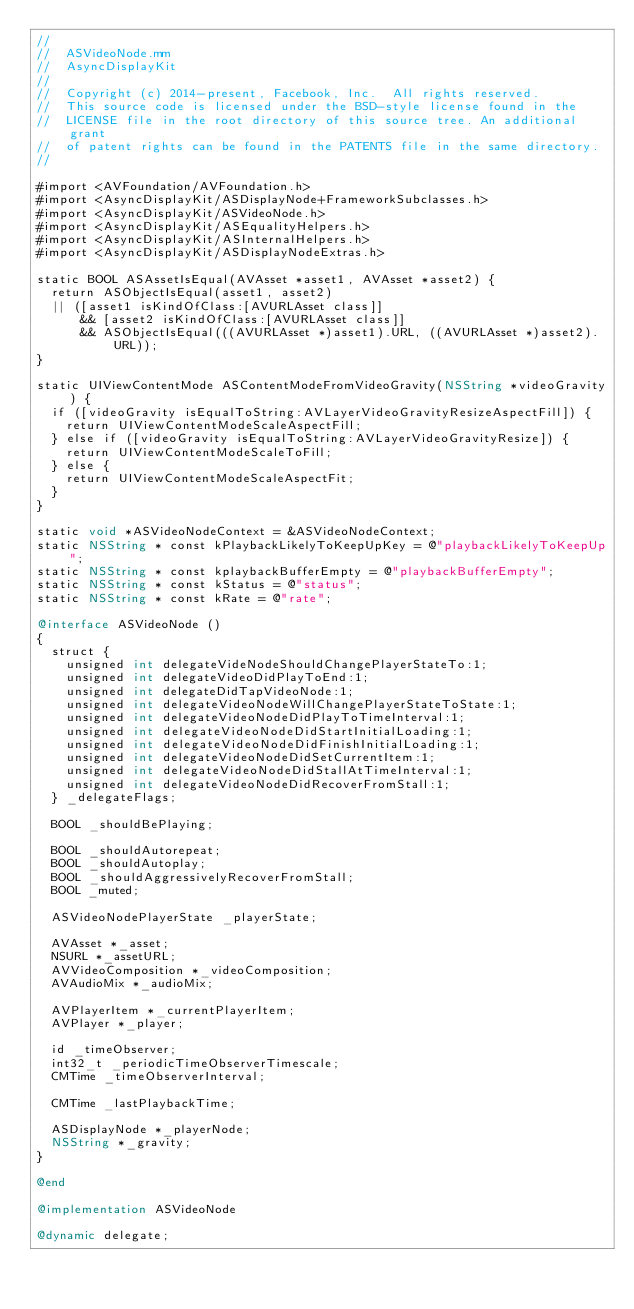Convert code to text. <code><loc_0><loc_0><loc_500><loc_500><_ObjectiveC_>//
//  ASVideoNode.mm
//  AsyncDisplayKit
//
//  Copyright (c) 2014-present, Facebook, Inc.  All rights reserved.
//  This source code is licensed under the BSD-style license found in the
//  LICENSE file in the root directory of this source tree. An additional grant
//  of patent rights can be found in the PATENTS file in the same directory.
//

#import <AVFoundation/AVFoundation.h>
#import <AsyncDisplayKit/ASDisplayNode+FrameworkSubclasses.h>
#import <AsyncDisplayKit/ASVideoNode.h>
#import <AsyncDisplayKit/ASEqualityHelpers.h>
#import <AsyncDisplayKit/ASInternalHelpers.h>
#import <AsyncDisplayKit/ASDisplayNodeExtras.h>

static BOOL ASAssetIsEqual(AVAsset *asset1, AVAsset *asset2) {
  return ASObjectIsEqual(asset1, asset2)
  || ([asset1 isKindOfClass:[AVURLAsset class]]
      && [asset2 isKindOfClass:[AVURLAsset class]]
      && ASObjectIsEqual(((AVURLAsset *)asset1).URL, ((AVURLAsset *)asset2).URL));
}

static UIViewContentMode ASContentModeFromVideoGravity(NSString *videoGravity) {
  if ([videoGravity isEqualToString:AVLayerVideoGravityResizeAspectFill]) {
    return UIViewContentModeScaleAspectFill;
  } else if ([videoGravity isEqualToString:AVLayerVideoGravityResize]) {
    return UIViewContentModeScaleToFill;
  } else {
    return UIViewContentModeScaleAspectFit;
  }
}

static void *ASVideoNodeContext = &ASVideoNodeContext;
static NSString * const kPlaybackLikelyToKeepUpKey = @"playbackLikelyToKeepUp";
static NSString * const kplaybackBufferEmpty = @"playbackBufferEmpty";
static NSString * const kStatus = @"status";
static NSString * const kRate = @"rate";

@interface ASVideoNode ()
{
  struct {
    unsigned int delegateVideNodeShouldChangePlayerStateTo:1;
    unsigned int delegateVideoDidPlayToEnd:1;
    unsigned int delegateDidTapVideoNode:1;
    unsigned int delegateVideoNodeWillChangePlayerStateToState:1;
    unsigned int delegateVideoNodeDidPlayToTimeInterval:1;
    unsigned int delegateVideoNodeDidStartInitialLoading:1;
    unsigned int delegateVideoNodeDidFinishInitialLoading:1;
    unsigned int delegateVideoNodeDidSetCurrentItem:1;
    unsigned int delegateVideoNodeDidStallAtTimeInterval:1;
    unsigned int delegateVideoNodeDidRecoverFromStall:1;
  } _delegateFlags;
  
  BOOL _shouldBePlaying;
  
  BOOL _shouldAutorepeat;
  BOOL _shouldAutoplay;
  BOOL _shouldAggressivelyRecoverFromStall;
  BOOL _muted;
  
  ASVideoNodePlayerState _playerState;
  
  AVAsset *_asset;
  NSURL *_assetURL;
  AVVideoComposition *_videoComposition;
  AVAudioMix *_audioMix;
  
  AVPlayerItem *_currentPlayerItem;
  AVPlayer *_player;
  
  id _timeObserver;
  int32_t _periodicTimeObserverTimescale;
  CMTime _timeObserverInterval;
  
  CMTime _lastPlaybackTime;
	
  ASDisplayNode *_playerNode;
  NSString *_gravity;
}

@end

@implementation ASVideoNode

@dynamic delegate;
</code> 